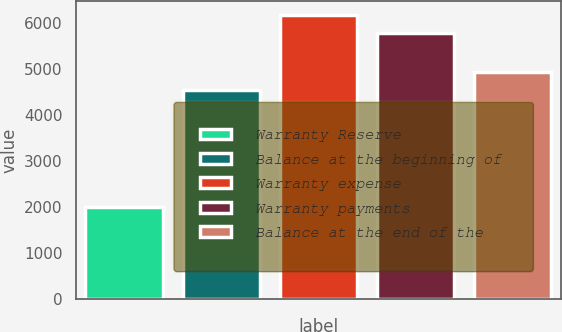<chart> <loc_0><loc_0><loc_500><loc_500><bar_chart><fcel>Warranty Reserve<fcel>Balance at the beginning of<fcel>Warranty expense<fcel>Warranty payments<fcel>Balance at the end of the<nl><fcel>2011<fcel>4554<fcel>6181.5<fcel>5797<fcel>4938.5<nl></chart> 